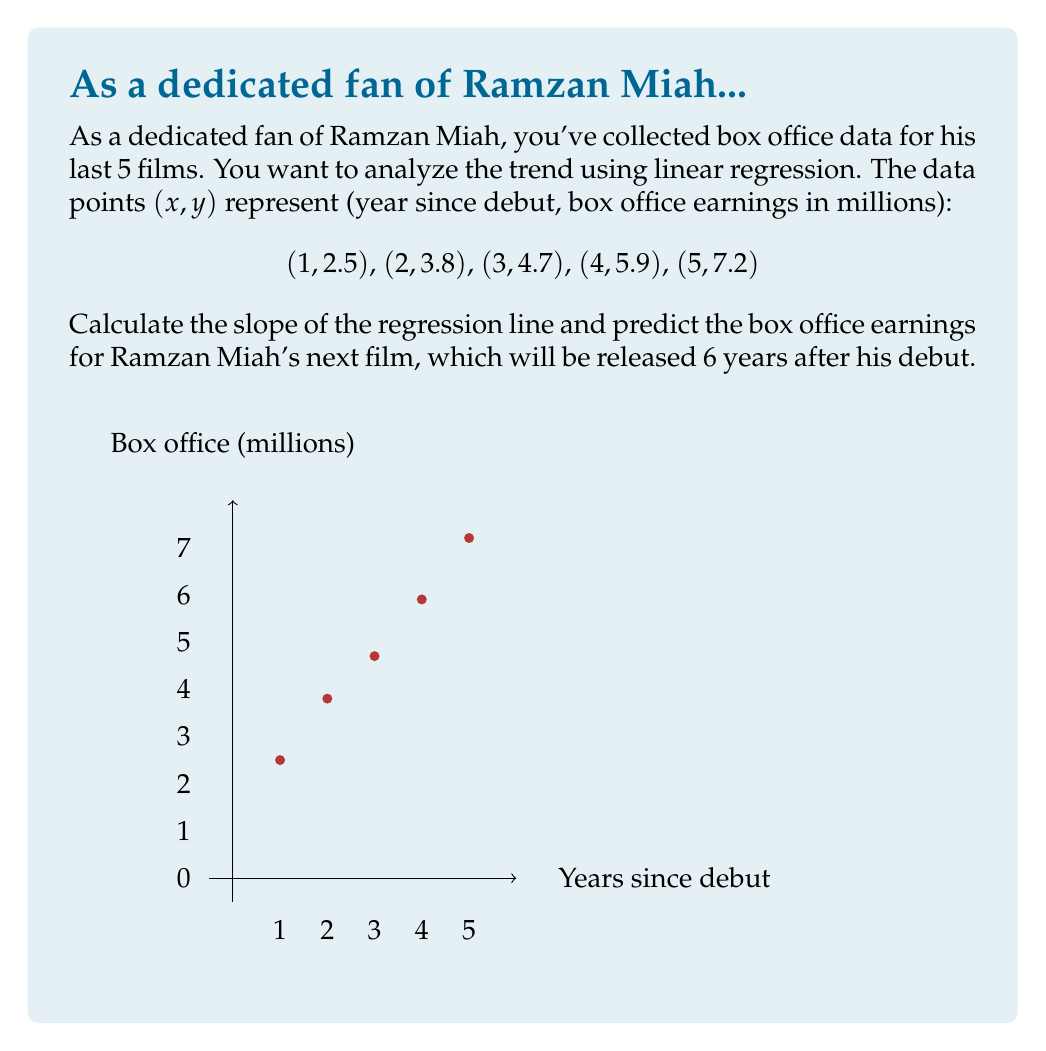Can you solve this math problem? Let's approach this step-by-step using the linear regression formula:

1) First, we need to calculate the following sums:
   $\sum x = 1 + 2 + 3 + 4 + 5 = 15$
   $\sum y = 2.5 + 3.8 + 4.7 + 5.9 + 7.2 = 24.1$
   $\sum xy = 1(2.5) + 2(3.8) + 3(4.7) + 4(5.9) + 5(7.2) = 91.3$
   $\sum x^2 = 1^2 + 2^2 + 3^2 + 4^2 + 5^2 = 55$
   $n = 5$ (number of data points)

2) The slope (m) of the regression line is given by:

   $$m = \frac{n\sum xy - \sum x \sum y}{n\sum x^2 - (\sum x)^2}$$

3) Substituting our values:

   $$m = \frac{5(91.3) - 15(24.1)}{5(55) - 15^2} = \frac{456.5 - 361.5}{275 - 225} = \frac{95}{50} = 1.9$$

4) The slope is 1.9, meaning the box office earnings increase by $1.9 million per year on average.

5) To predict the earnings for the 6th year, we can use the point-slope form of a line:
   $y - y_1 = m(x - x_1)$, where $(x_1, y_1)$ is any point on the line. Let's use the last data point (5, 7.2).

6) Substituting x = 6 (6th year):
   $y - 7.2 = 1.9(6 - 5)$
   $y - 7.2 = 1.9$
   $y = 9.1$

Therefore, the predicted box office earnings for Ramzan Miah's next film, 6 years after his debut, is $9.1 million.
Answer: Slope: 1.9; Predicted earnings: $9.1 million 